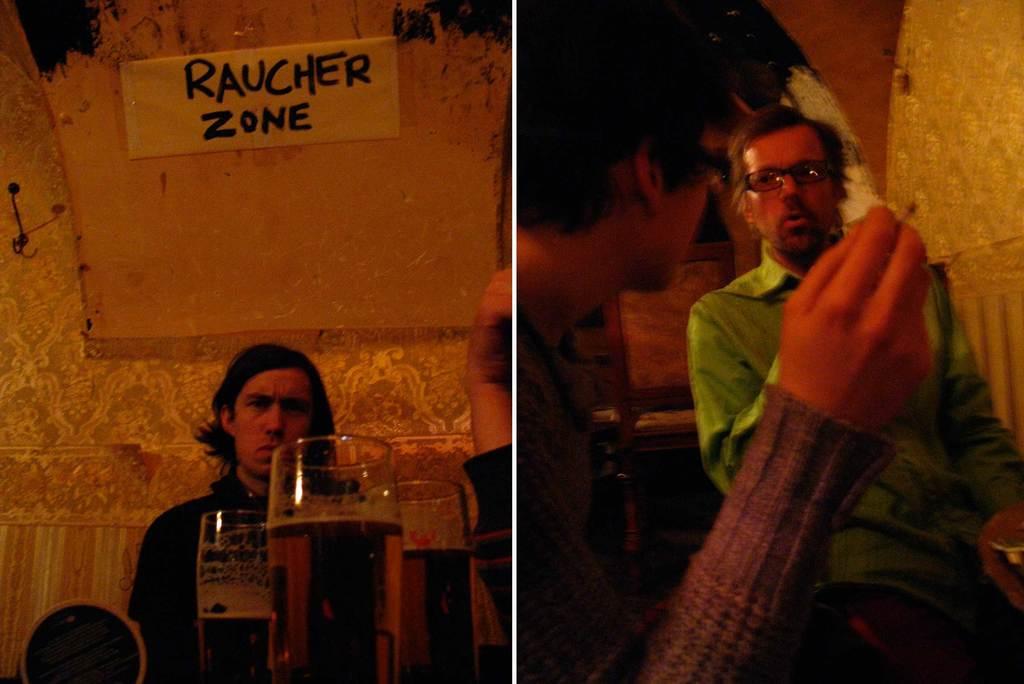What is the name of the area that the man on the left is sitting in?
Your answer should be compact. Raucher zone. 